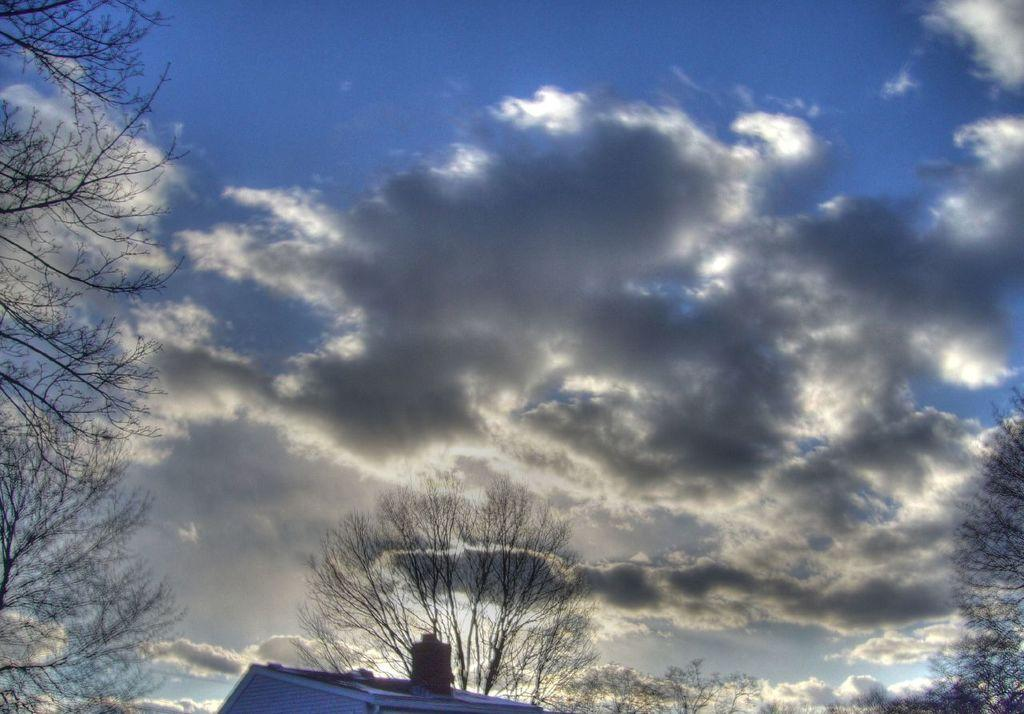What type of vegetation is visible in the image? There are trees in the image. What can be seen in the sky in the background of the image? There are clouds in the sky in the background of the image. How many pizzas are being held by the girl in the image? There is no girl or pizzas present in the image; it only features trees and clouds in the sky. 